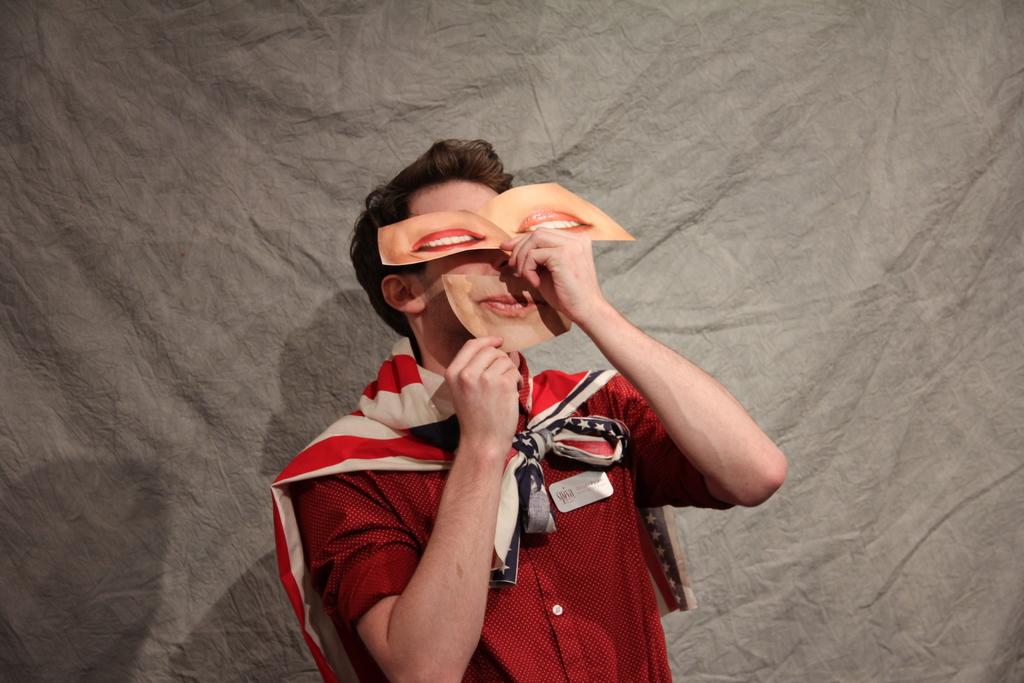Who is present in the image? There is a man in the image. What is the man holding near his face? The man is holding lips cards in his hands near his face. What is covering the man's shoulders? There is a cloth on the man's shoulders. What can be seen in the background of the image? There is a cloth visible in the background of the image. What type of war is being depicted in the image? There is no depiction of war in the image; it features a man holding lips cards and wearing a cloth on his shoulders. What town can be seen in the background of the image? There is no town visible in the background of the image; it only shows a cloth. 